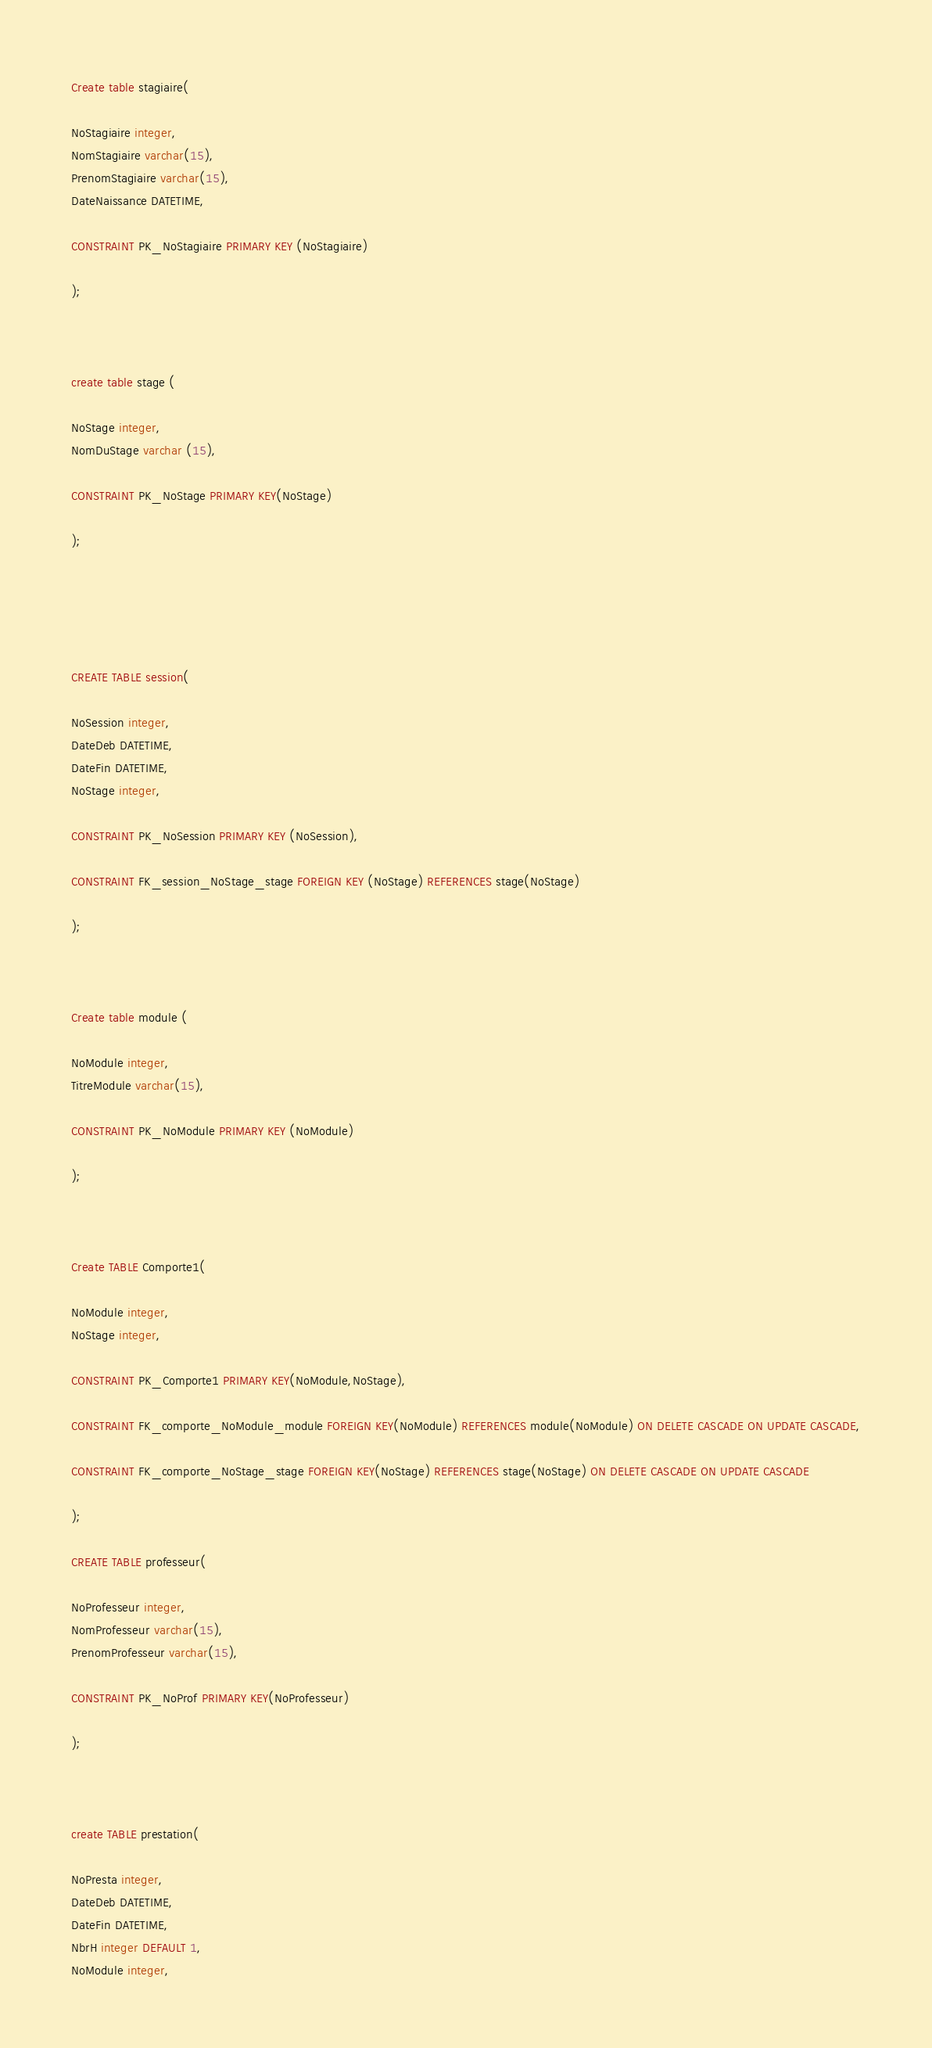<code> <loc_0><loc_0><loc_500><loc_500><_SQL_>Create table stagiaire(

NoStagiaire integer,
NomStagiaire varchar(15),
PrenomStagiaire varchar(15),
DateNaissance DATETIME,

CONSTRAINT PK_NoStagiaire PRIMARY KEY (NoStagiaire)

);



create table stage (

NoStage integer,
NomDuStage varchar (15),

CONSTRAINT PK_NoStage PRIMARY KEY(NoStage)

);





CREATE TABLE session(

NoSession integer,
DateDeb DATETIME,
DateFin DATETIME,
NoStage integer,

CONSTRAINT PK_NoSession PRIMARY KEY (NoSession),

CONSTRAINT FK_session_NoStage_stage FOREIGN KEY (NoStage) REFERENCES stage(NoStage)

);



Create table module (

NoModule integer,
TitreModule varchar(15),

CONSTRAINT PK_NoModule PRIMARY KEY (NoModule)

);



Create TABLE Comporte1(

NoModule integer,
NoStage integer,

CONSTRAINT PK_Comporte1 PRIMARY KEY(NoModule,NoStage),

CONSTRAINT FK_comporte_NoModule_module FOREIGN KEY(NoModule) REFERENCES module(NoModule) ON DELETE CASCADE ON UPDATE CASCADE,

CONSTRAINT FK_comporte_NoStage_stage FOREIGN KEY(NoStage) REFERENCES stage(NoStage) ON DELETE CASCADE ON UPDATE CASCADE

);

CREATE TABLE professeur(

NoProfesseur integer,
NomProfesseur varchar(15),
PrenomProfesseur varchar(15),

CONSTRAINT PK_NoProf PRIMARY KEY(NoProfesseur)

);



create TABLE prestation(

NoPresta integer,
DateDeb DATETIME,
DateFin DATETIME,
NbrH integer DEFAULT 1,
NoModule integer,</code> 